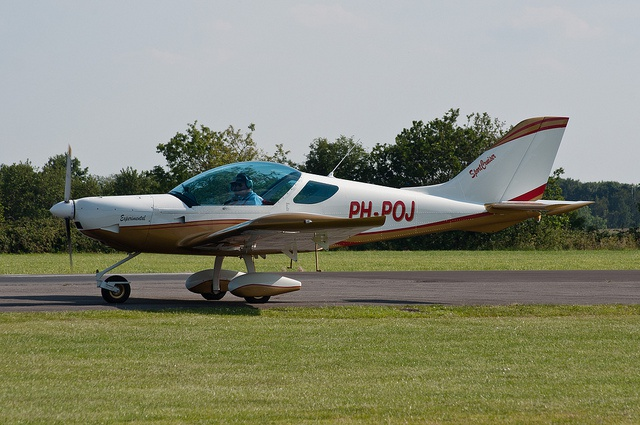Describe the objects in this image and their specific colors. I can see airplane in darkgray, black, gray, and maroon tones and people in darkgray, black, blue, darkblue, and lightblue tones in this image. 